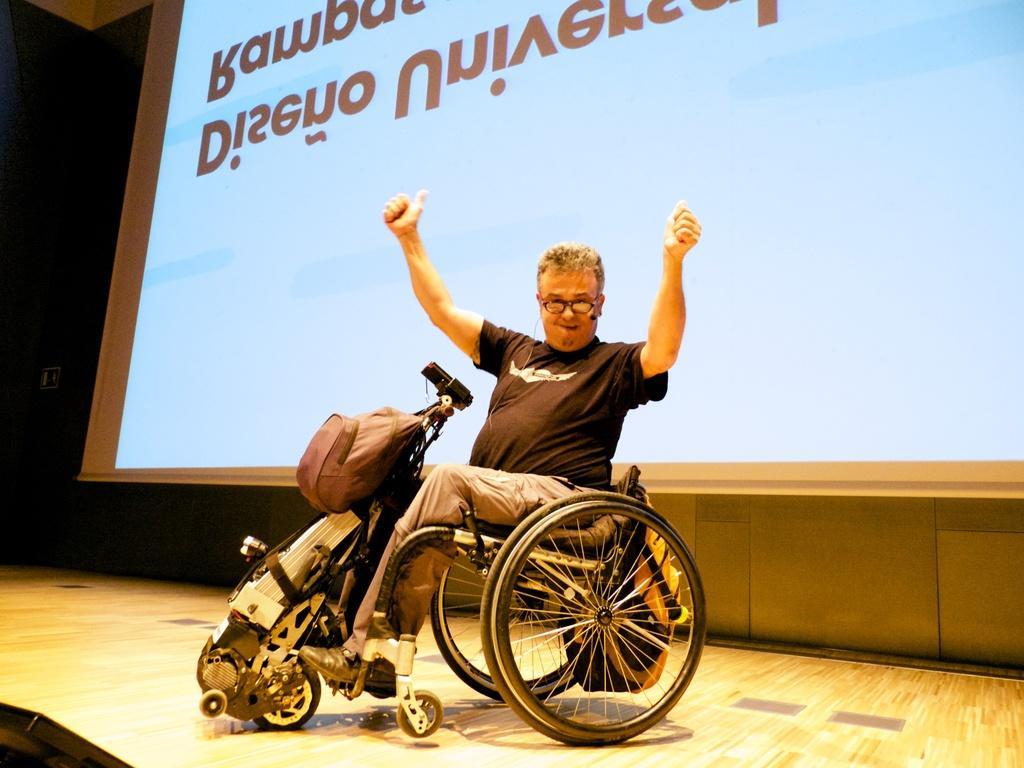How would you summarize this image in a sentence or two? There is a person wearing specs and mic is sitting on a wheelchair. On the wheelchair there is a bag. In the back there is a screen. 